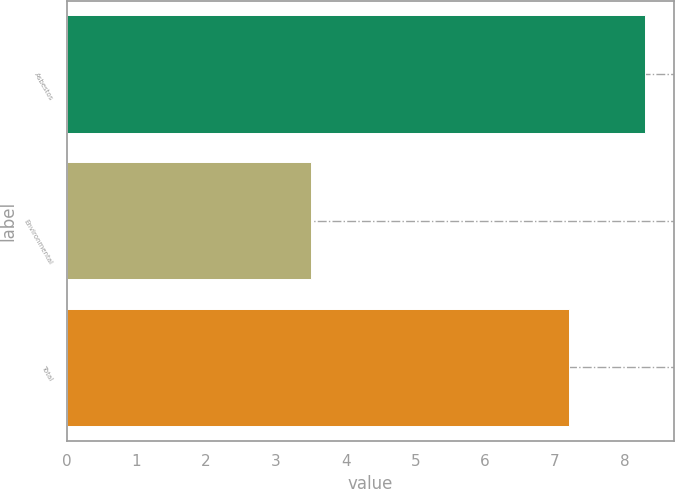<chart> <loc_0><loc_0><loc_500><loc_500><bar_chart><fcel>Asbestos<fcel>Environmental<fcel>Total<nl><fcel>8.3<fcel>3.5<fcel>7.2<nl></chart> 